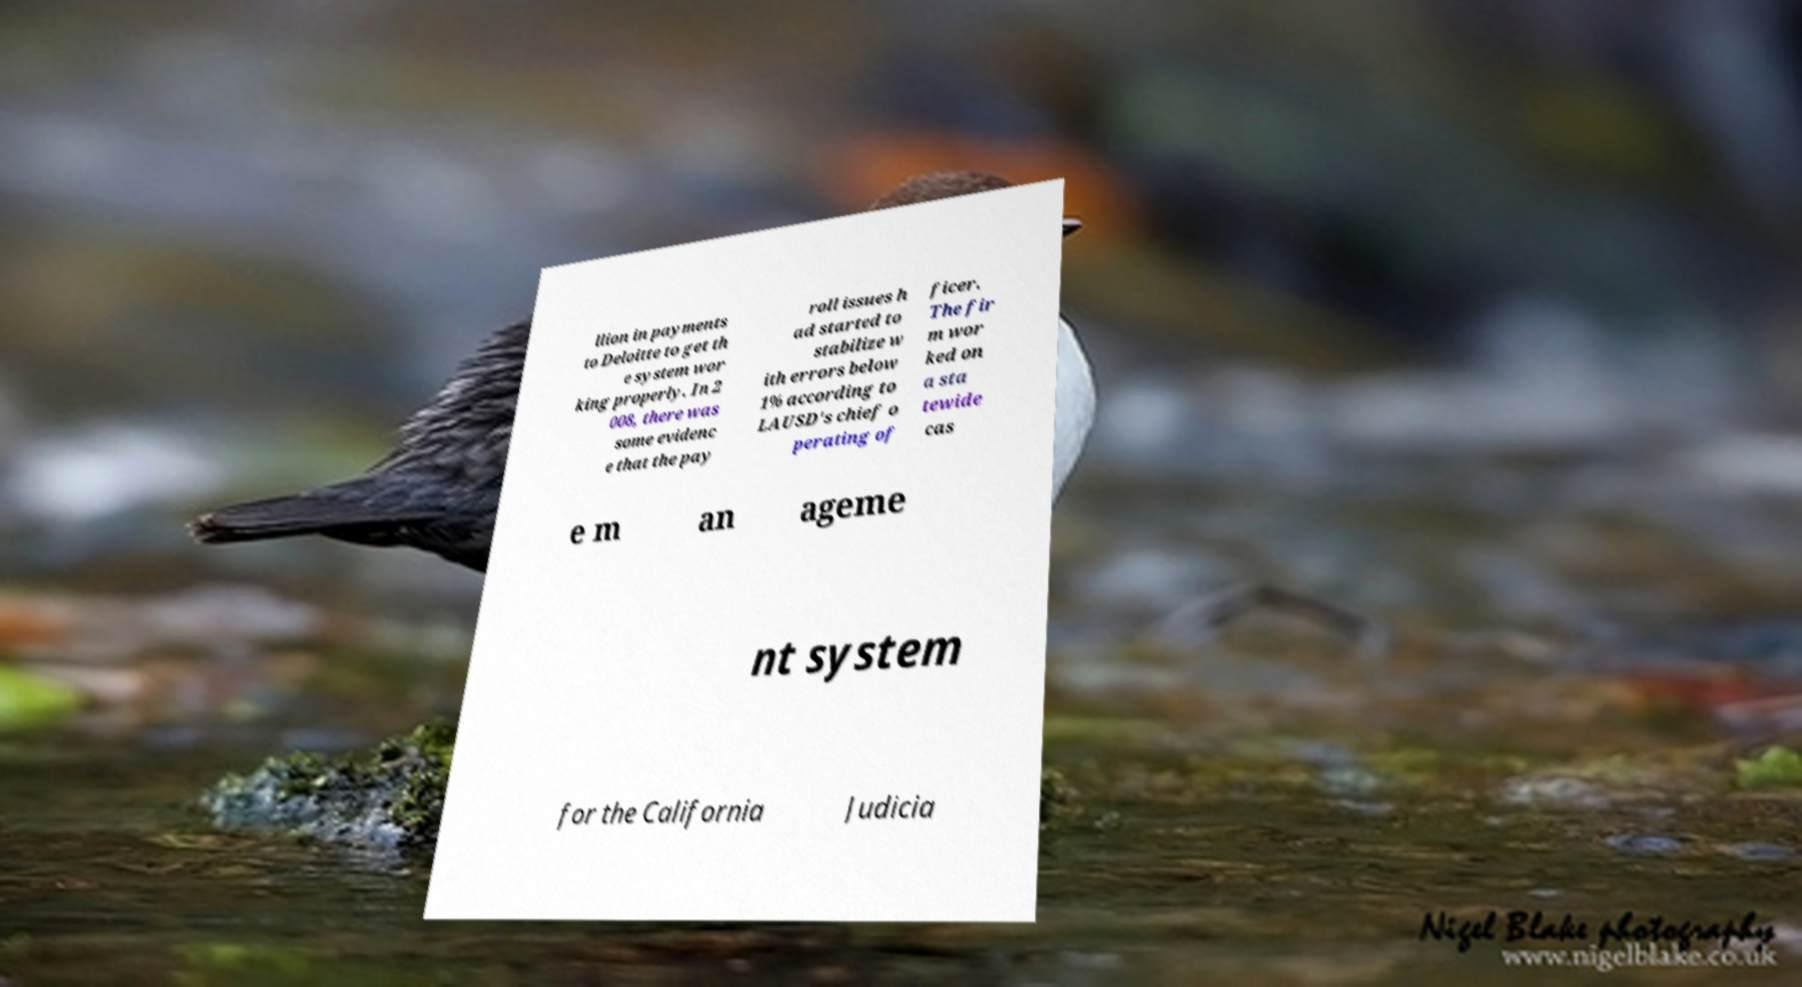Please read and relay the text visible in this image. What does it say? llion in payments to Deloitte to get th e system wor king properly. In 2 008, there was some evidenc e that the pay roll issues h ad started to stabilize w ith errors below 1% according to LAUSD's chief o perating of ficer. The fir m wor ked on a sta tewide cas e m an ageme nt system for the California Judicia 